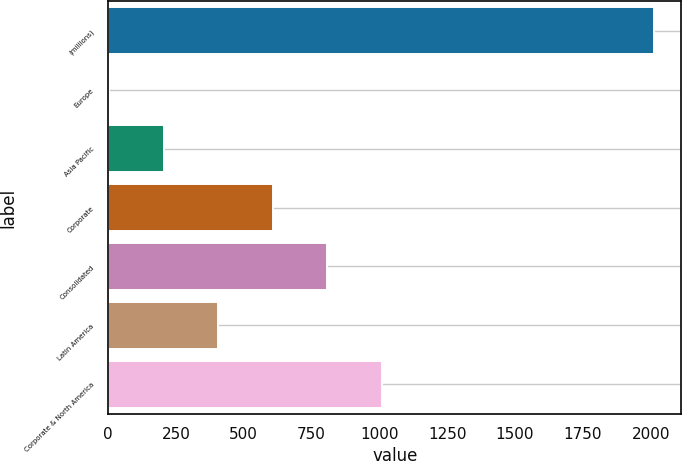Convert chart to OTSL. <chart><loc_0><loc_0><loc_500><loc_500><bar_chart><fcel>(millions)<fcel>Europe<fcel>Asia Pacific<fcel>Corporate<fcel>Consolidated<fcel>Latin America<fcel>Corporate & North America<nl><fcel>2012<fcel>4<fcel>204.8<fcel>606.4<fcel>807.2<fcel>405.6<fcel>1008<nl></chart> 